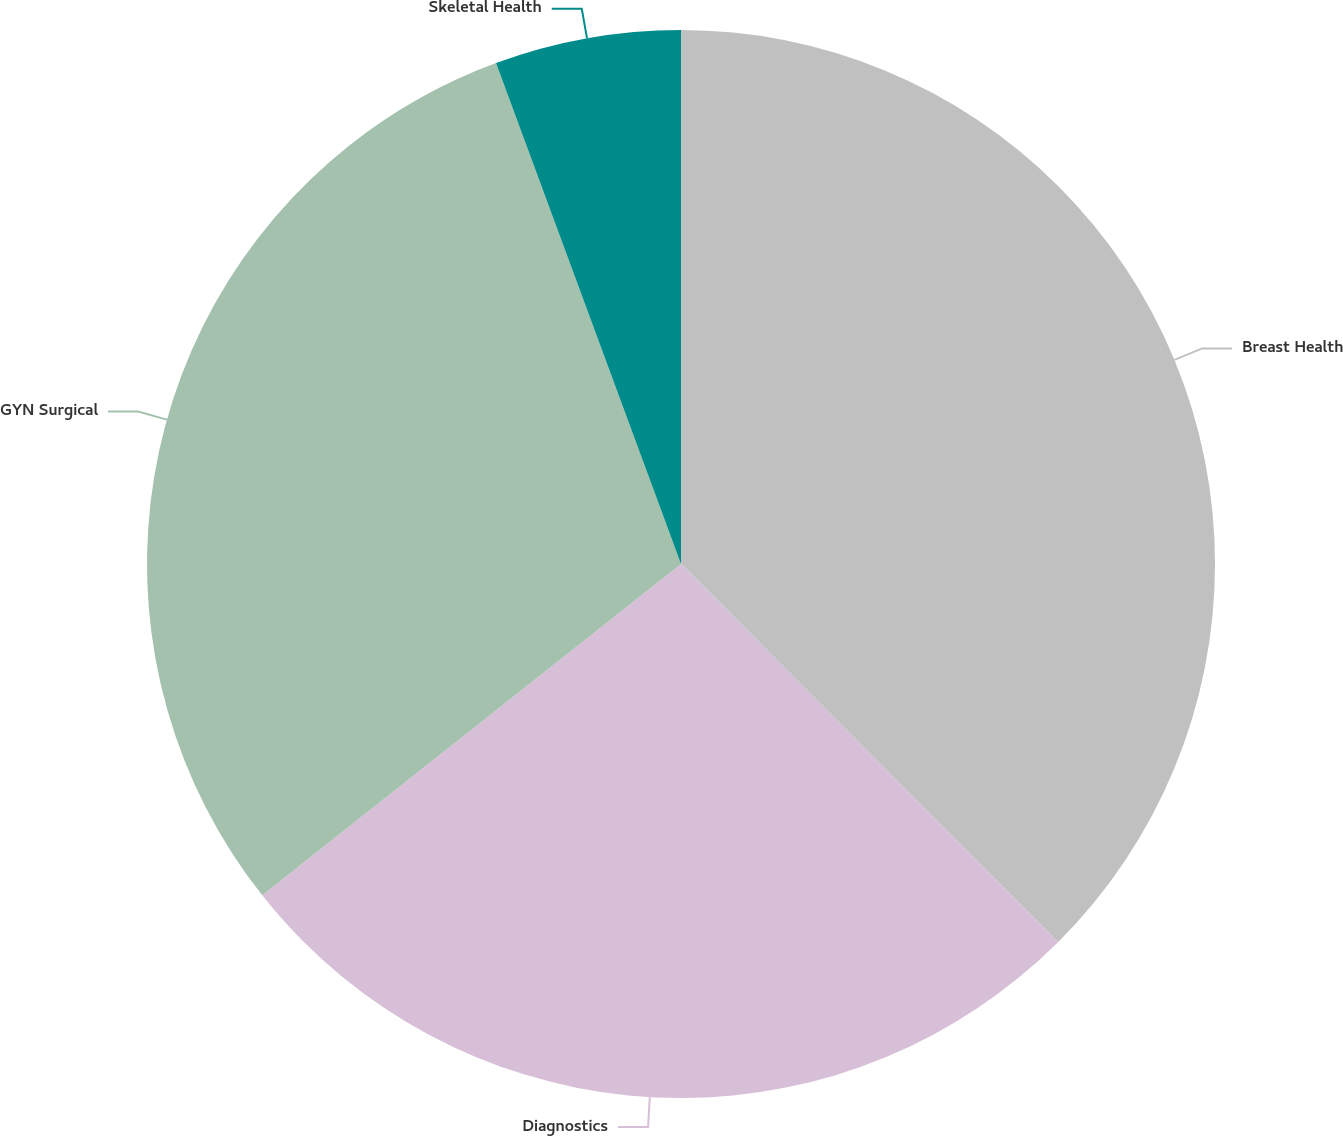Convert chart. <chart><loc_0><loc_0><loc_500><loc_500><pie_chart><fcel>Breast Health<fcel>Diagnostics<fcel>GYN Surgical<fcel>Skeletal Health<nl><fcel>37.51%<fcel>26.83%<fcel>30.02%<fcel>5.63%<nl></chart> 